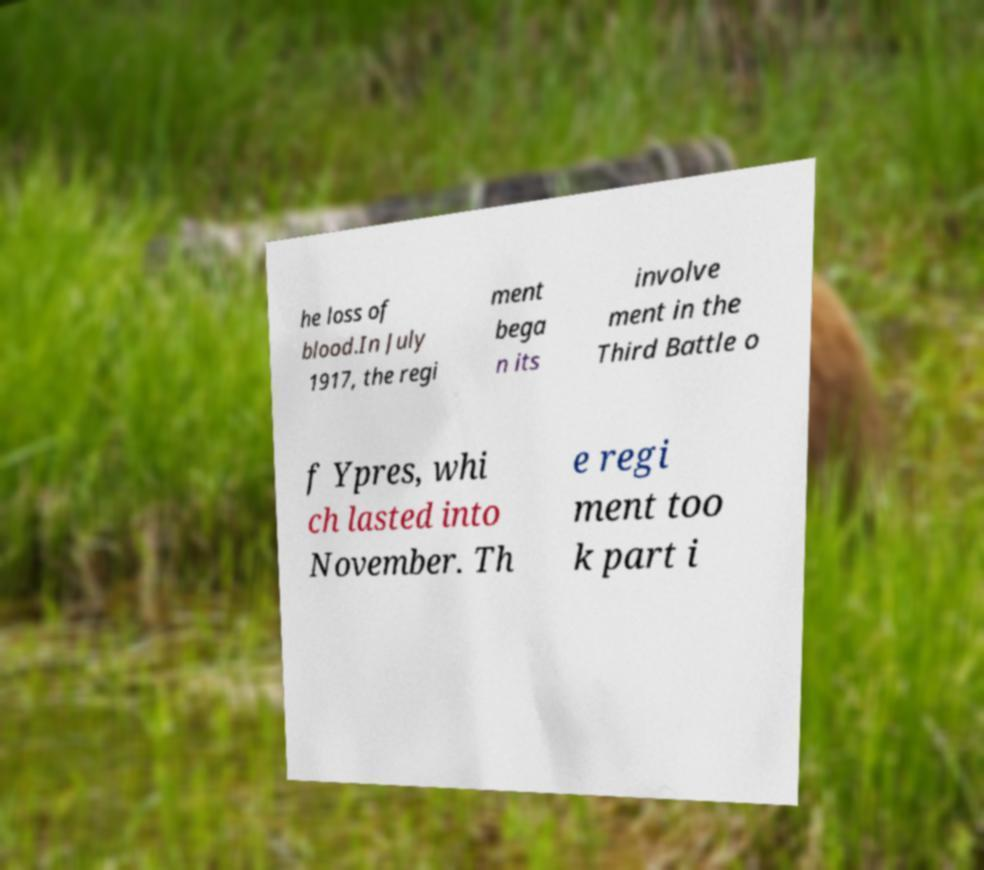What messages or text are displayed in this image? I need them in a readable, typed format. he loss of blood.In July 1917, the regi ment bega n its involve ment in the Third Battle o f Ypres, whi ch lasted into November. Th e regi ment too k part i 